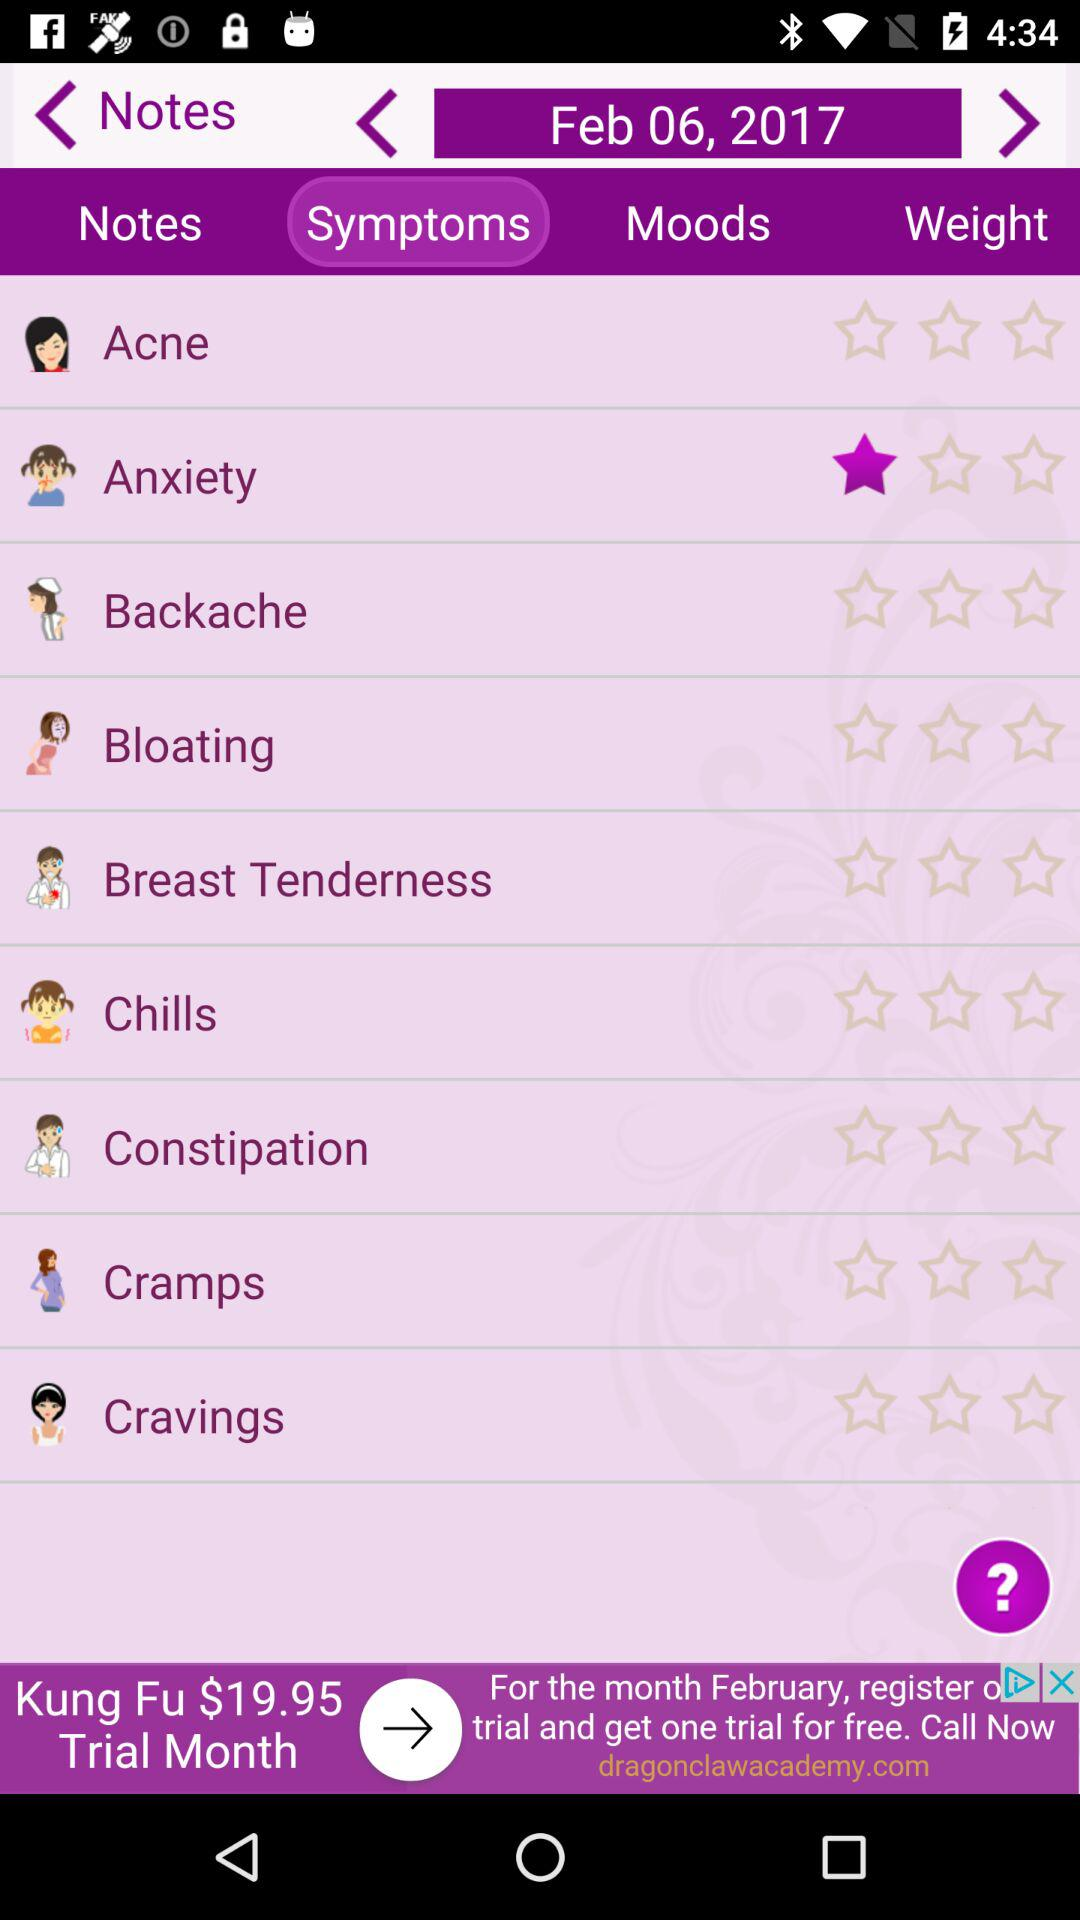Which tab am I using? The tab is "Symptoms". 